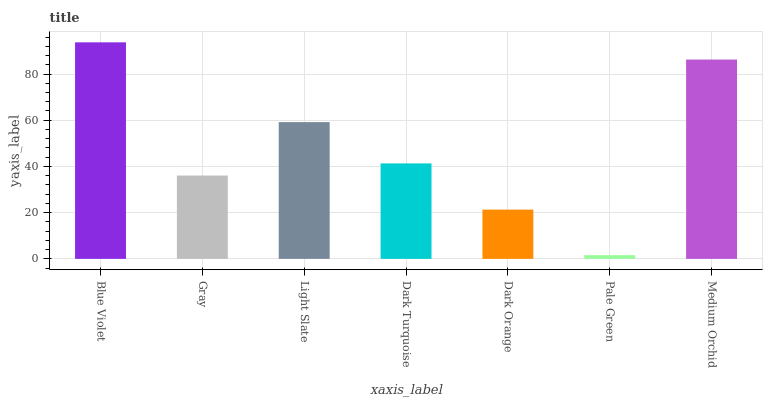Is Pale Green the minimum?
Answer yes or no. Yes. Is Blue Violet the maximum?
Answer yes or no. Yes. Is Gray the minimum?
Answer yes or no. No. Is Gray the maximum?
Answer yes or no. No. Is Blue Violet greater than Gray?
Answer yes or no. Yes. Is Gray less than Blue Violet?
Answer yes or no. Yes. Is Gray greater than Blue Violet?
Answer yes or no. No. Is Blue Violet less than Gray?
Answer yes or no. No. Is Dark Turquoise the high median?
Answer yes or no. Yes. Is Dark Turquoise the low median?
Answer yes or no. Yes. Is Medium Orchid the high median?
Answer yes or no. No. Is Gray the low median?
Answer yes or no. No. 